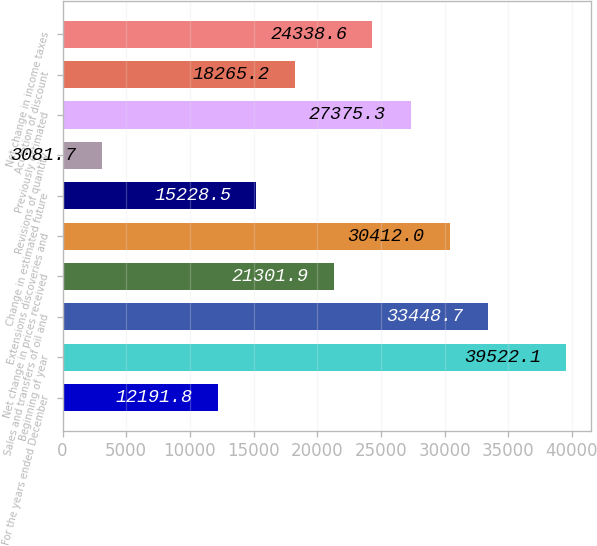Convert chart to OTSL. <chart><loc_0><loc_0><loc_500><loc_500><bar_chart><fcel>For the years ended December<fcel>Beginning of year<fcel>Sales and transfers of oil and<fcel>Net change in prices received<fcel>Extensions discoveries and<fcel>Change in estimated future<fcel>Revisions of quantity<fcel>Previously estimated<fcel>Accretion of discount<fcel>Net change in income taxes<nl><fcel>12191.8<fcel>39522.1<fcel>33448.7<fcel>21301.9<fcel>30412<fcel>15228.5<fcel>3081.7<fcel>27375.3<fcel>18265.2<fcel>24338.6<nl></chart> 